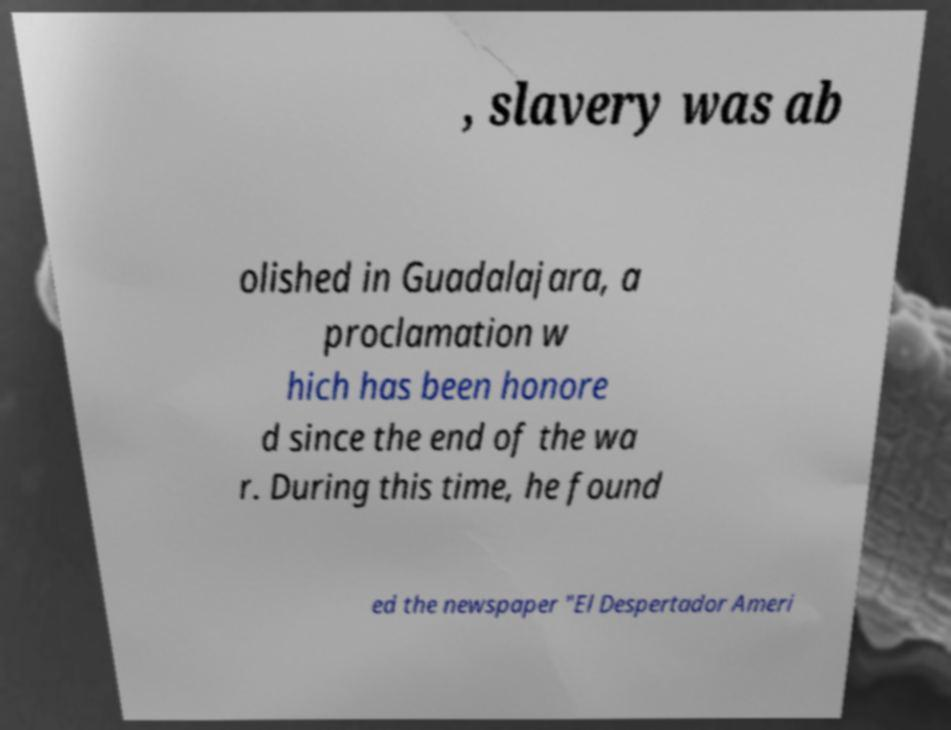Can you accurately transcribe the text from the provided image for me? , slavery was ab olished in Guadalajara, a proclamation w hich has been honore d since the end of the wa r. During this time, he found ed the newspaper "El Despertador Ameri 